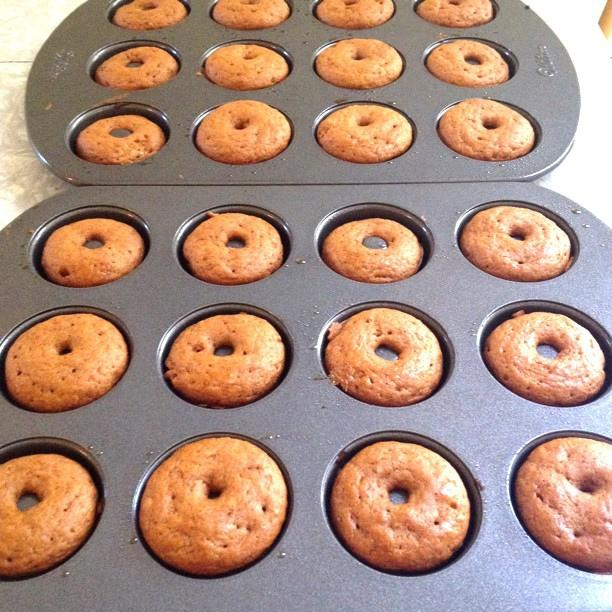What color are the donuts made from this strange pan?

Choices:
A) brown
B) black
C) purple
D) white brown 